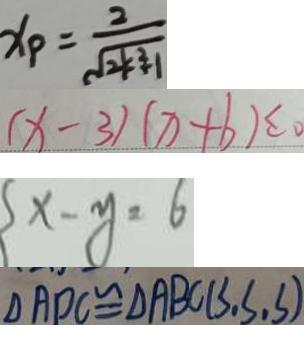Convert formula to latex. <formula><loc_0><loc_0><loc_500><loc_500>x _ { P } = \frac { 2 } { \sqrt { 2 k ^ { 2 } } + 1 } 
 ( x - 3 ) ( x + b ) \leq 0 
 x - y = 6 
 \Delta A D C \cong \Delta A B C ( S , S , S )</formula> 